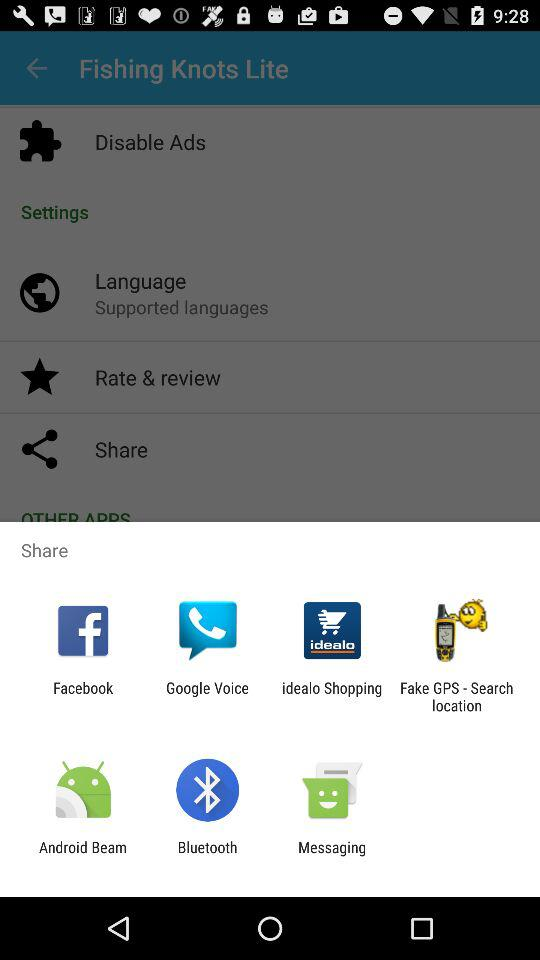Which application can be used to share? The applications that can be used to share are "Facebook", "Google Voice", "idealo Shopping", "Fake GPS - Search location", "Android Beam", "Bluetooth" and "Messaging". 